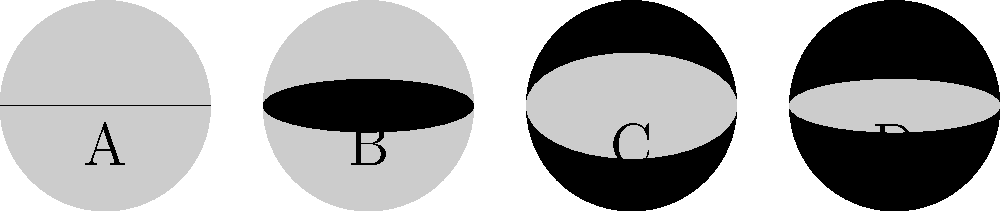In the installation process of a billiards table, you often need to consider lighting conditions. The Moon's phases can affect natural lighting through windows. Arrange the following Moon phases in the correct chronological order: New Moon, First Quarter, Full Moon, Last Quarter. To answer this question, we need to understand the sequence of the Moon's phases and match them to the given diagrams:

1. Diagram A shows a completely dark circle, representing the New Moon.
2. Diagram B shows a half-illuminated circle on the right side, representing the First Quarter.
3. Diagram C shows a fully illuminated circle, representing the Full Moon.
4. Diagram D shows a half-illuminated circle on the left side, representing the Last Quarter.

The correct chronological order of these phases is:

1. New Moon (A): The Moon is between the Earth and the Sun, so we see the dark side.
2. First Quarter (B): A week after the New Moon, we see half of the illuminated surface.
3. Full Moon (C): The Moon is on the opposite side of Earth from the Sun, fully illuminated.
4. Last Quarter (D): A week after the Full Moon, we again see half of the illuminated surface, but on the opposite side compared to the First Quarter.

This cycle repeats approximately every 29.5 days.
Answer: A, B, C, D 